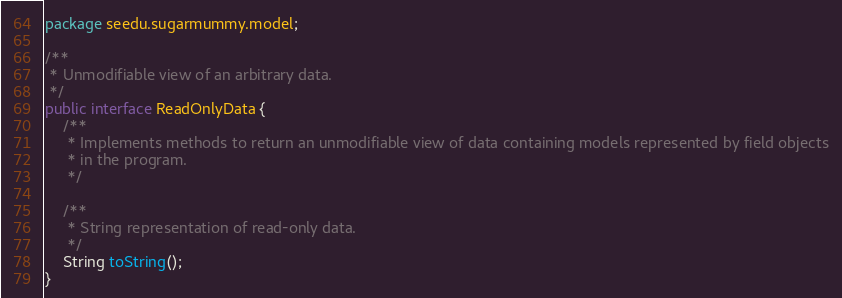<code> <loc_0><loc_0><loc_500><loc_500><_Java_>package seedu.sugarmummy.model;

/**
 * Unmodifiable view of an arbitrary data.
 */
public interface ReadOnlyData {
    /**
     * Implements methods to return an unmodifiable view of data containing models represented by field objects
     * in the program.
     */

    /**
     * String representation of read-only data.
     */
    String toString();
}
</code> 